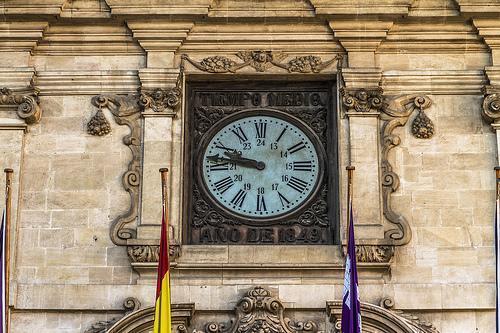How many clocks are there?
Give a very brief answer. 1. How many people are eating donuts?
Give a very brief answer. 0. How many elephants are pictured?
Give a very brief answer. 0. How many flags have yellow on them?
Give a very brief answer. 1. 